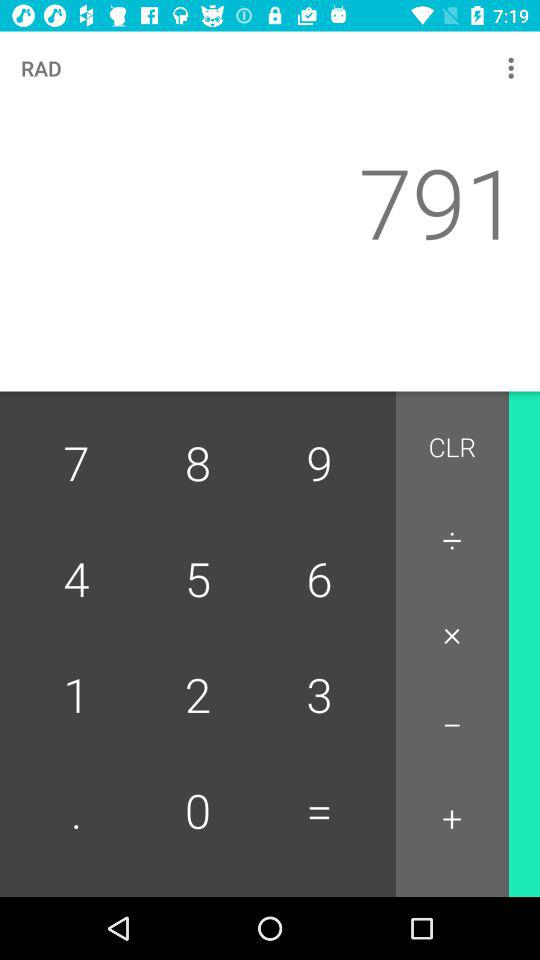What is the calculated number? The calculated number is 791. 